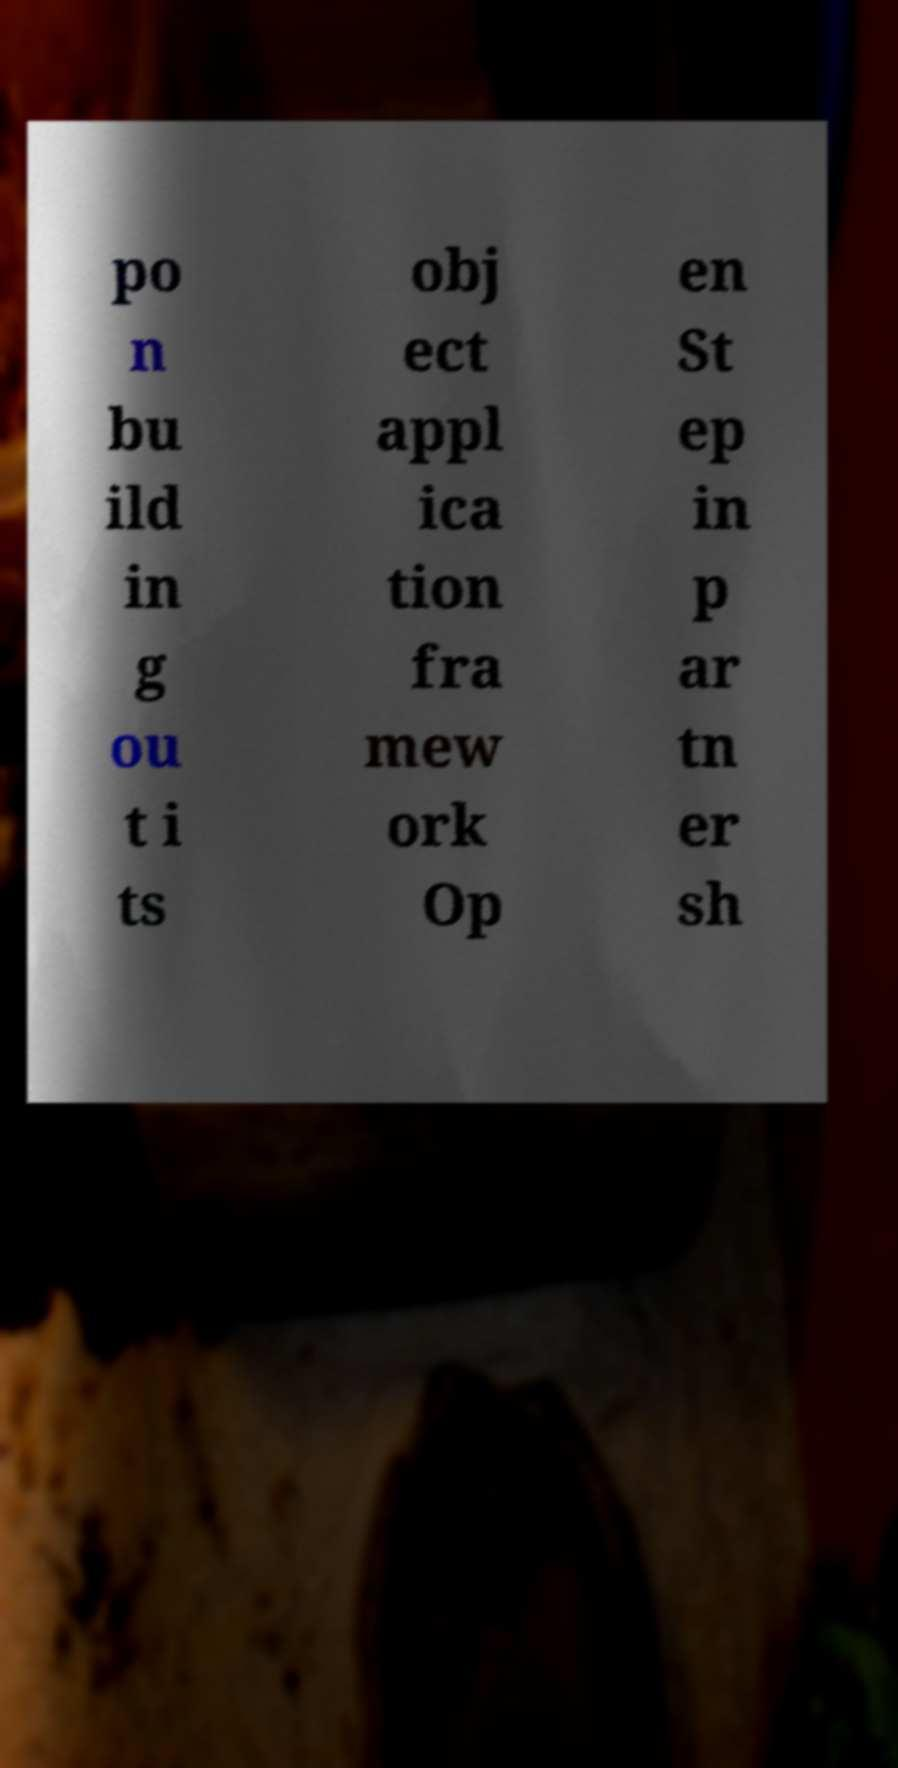Can you read and provide the text displayed in the image?This photo seems to have some interesting text. Can you extract and type it out for me? po n bu ild in g ou t i ts obj ect appl ica tion fra mew ork Op en St ep in p ar tn er sh 